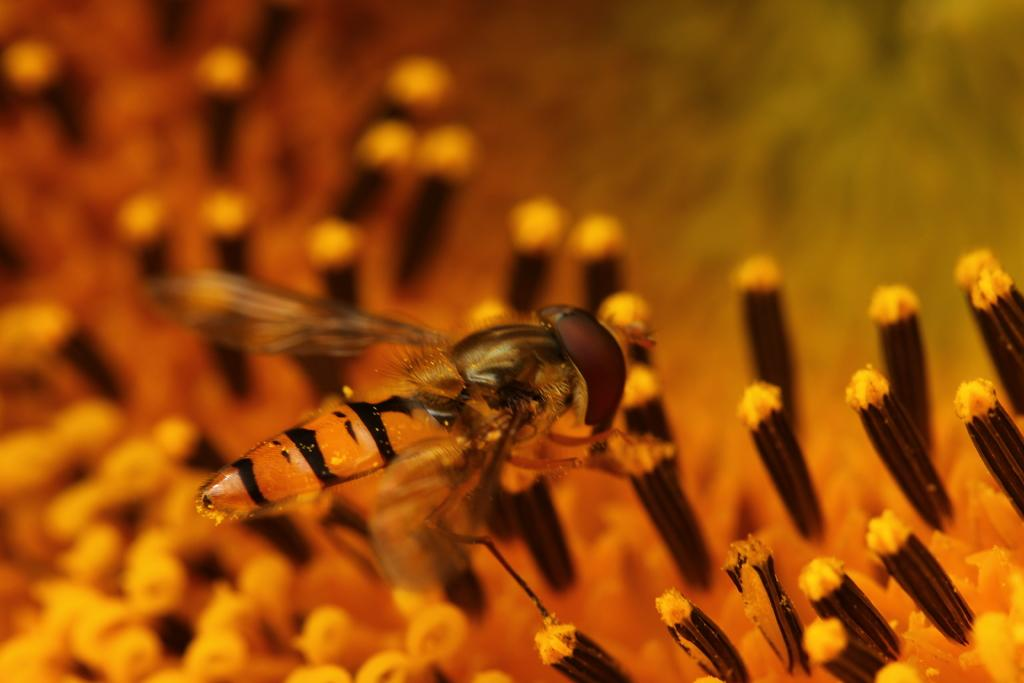What type of insect is in the image? There is a honey bee in the image. What colors are present in the image? There are brown and yellow color things in the image. How would you describe the background of the image? The background of the image is blurred. What idea does the honey bee have about respecting mass in the image? There is no indication in the image that the honey bee has any ideas about respecting mass, as insects do not have the cognitive ability to form such ideas. 